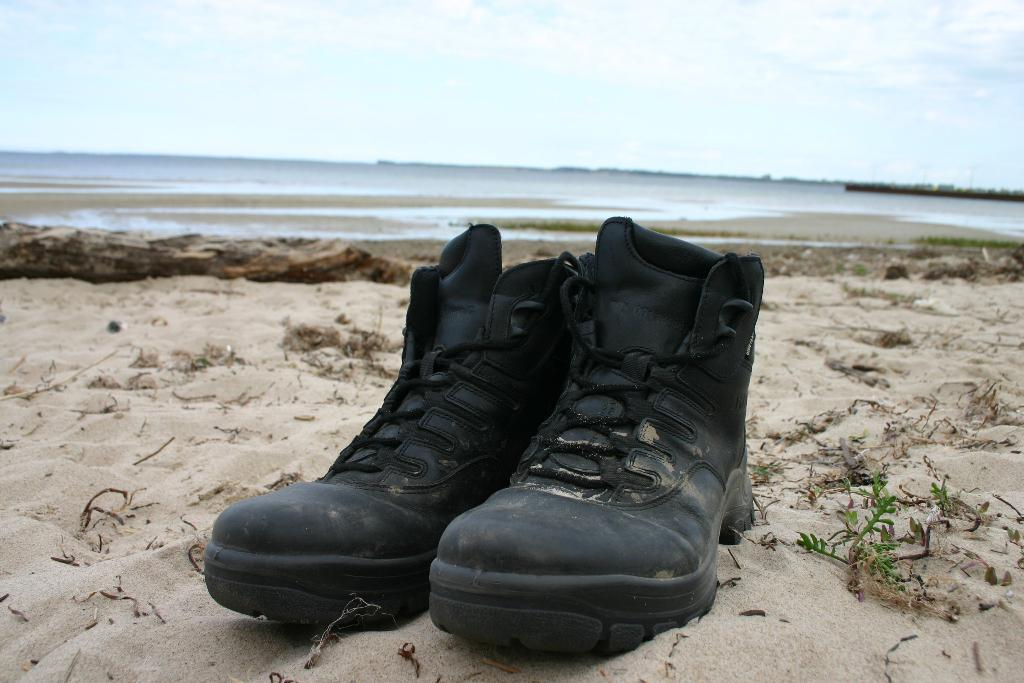What objects are on the sand in the image? There is a pair of shoes on the sand. What can be seen in the distance in the image? There is a river in the background of the image. What is visible above the river in the image? The sky is visible in the background of the image. What time of day is it in the image, given the presence of the moon? There is no moon visible in the image, so it is not possible to determine the time of day based on that information. 